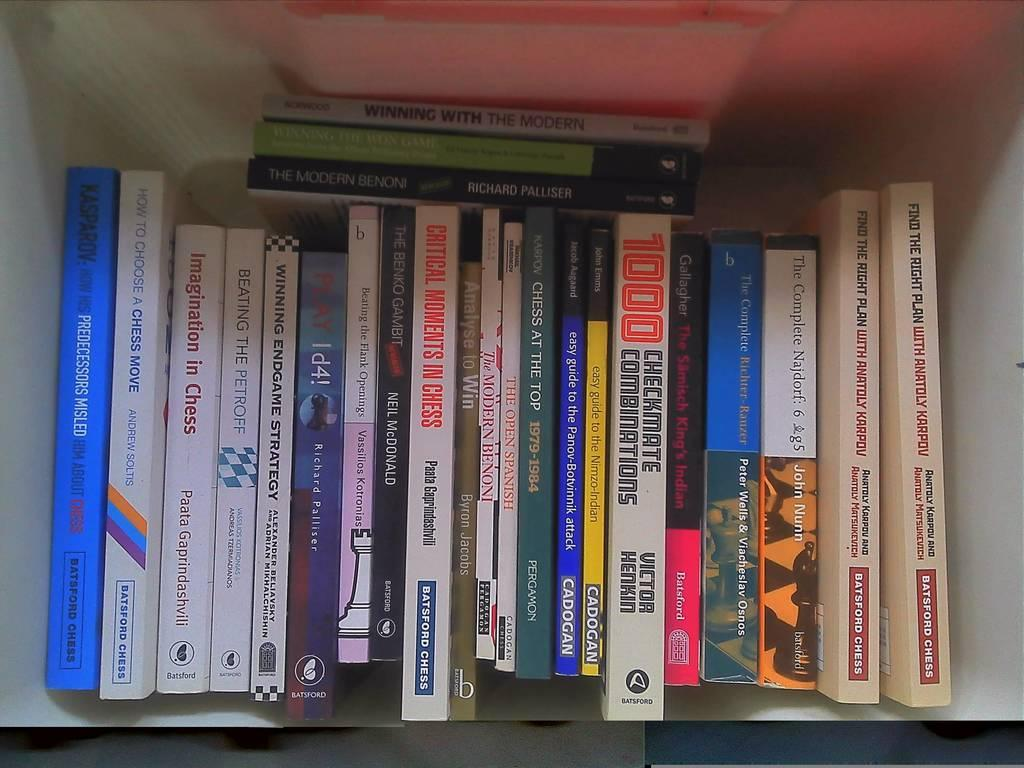<image>
Present a compact description of the photo's key features. Books about chess and chess strategy on a shelf. 